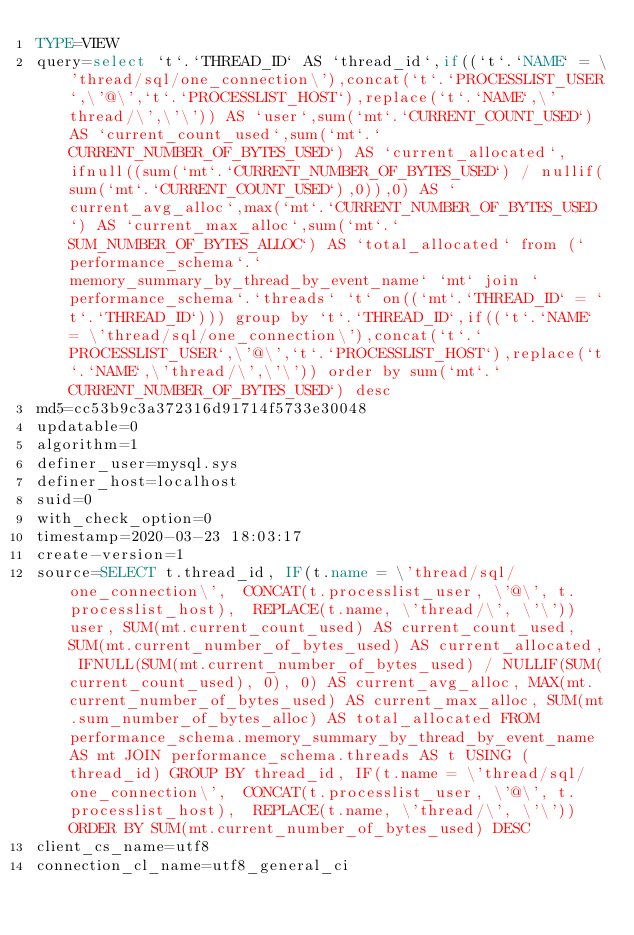Convert code to text. <code><loc_0><loc_0><loc_500><loc_500><_VisualBasic_>TYPE=VIEW
query=select `t`.`THREAD_ID` AS `thread_id`,if((`t`.`NAME` = \'thread/sql/one_connection\'),concat(`t`.`PROCESSLIST_USER`,\'@\',`t`.`PROCESSLIST_HOST`),replace(`t`.`NAME`,\'thread/\',\'\')) AS `user`,sum(`mt`.`CURRENT_COUNT_USED`) AS `current_count_used`,sum(`mt`.`CURRENT_NUMBER_OF_BYTES_USED`) AS `current_allocated`,ifnull((sum(`mt`.`CURRENT_NUMBER_OF_BYTES_USED`) / nullif(sum(`mt`.`CURRENT_COUNT_USED`),0)),0) AS `current_avg_alloc`,max(`mt`.`CURRENT_NUMBER_OF_BYTES_USED`) AS `current_max_alloc`,sum(`mt`.`SUM_NUMBER_OF_BYTES_ALLOC`) AS `total_allocated` from (`performance_schema`.`memory_summary_by_thread_by_event_name` `mt` join `performance_schema`.`threads` `t` on((`mt`.`THREAD_ID` = `t`.`THREAD_ID`))) group by `t`.`THREAD_ID`,if((`t`.`NAME` = \'thread/sql/one_connection\'),concat(`t`.`PROCESSLIST_USER`,\'@\',`t`.`PROCESSLIST_HOST`),replace(`t`.`NAME`,\'thread/\',\'\')) order by sum(`mt`.`CURRENT_NUMBER_OF_BYTES_USED`) desc
md5=cc53b9c3a372316d91714f5733e30048
updatable=0
algorithm=1
definer_user=mysql.sys
definer_host=localhost
suid=0
with_check_option=0
timestamp=2020-03-23 18:03:17
create-version=1
source=SELECT t.thread_id, IF(t.name = \'thread/sql/one_connection\',  CONCAT(t.processlist_user, \'@\', t.processlist_host),  REPLACE(t.name, \'thread/\', \'\')) user, SUM(mt.current_count_used) AS current_count_used, SUM(mt.current_number_of_bytes_used) AS current_allocated, IFNULL(SUM(mt.current_number_of_bytes_used) / NULLIF(SUM(current_count_used), 0), 0) AS current_avg_alloc, MAX(mt.current_number_of_bytes_used) AS current_max_alloc, SUM(mt.sum_number_of_bytes_alloc) AS total_allocated FROM performance_schema.memory_summary_by_thread_by_event_name AS mt JOIN performance_schema.threads AS t USING (thread_id) GROUP BY thread_id, IF(t.name = \'thread/sql/one_connection\',  CONCAT(t.processlist_user, \'@\', t.processlist_host),  REPLACE(t.name, \'thread/\', \'\')) ORDER BY SUM(mt.current_number_of_bytes_used) DESC
client_cs_name=utf8
connection_cl_name=utf8_general_ci</code> 